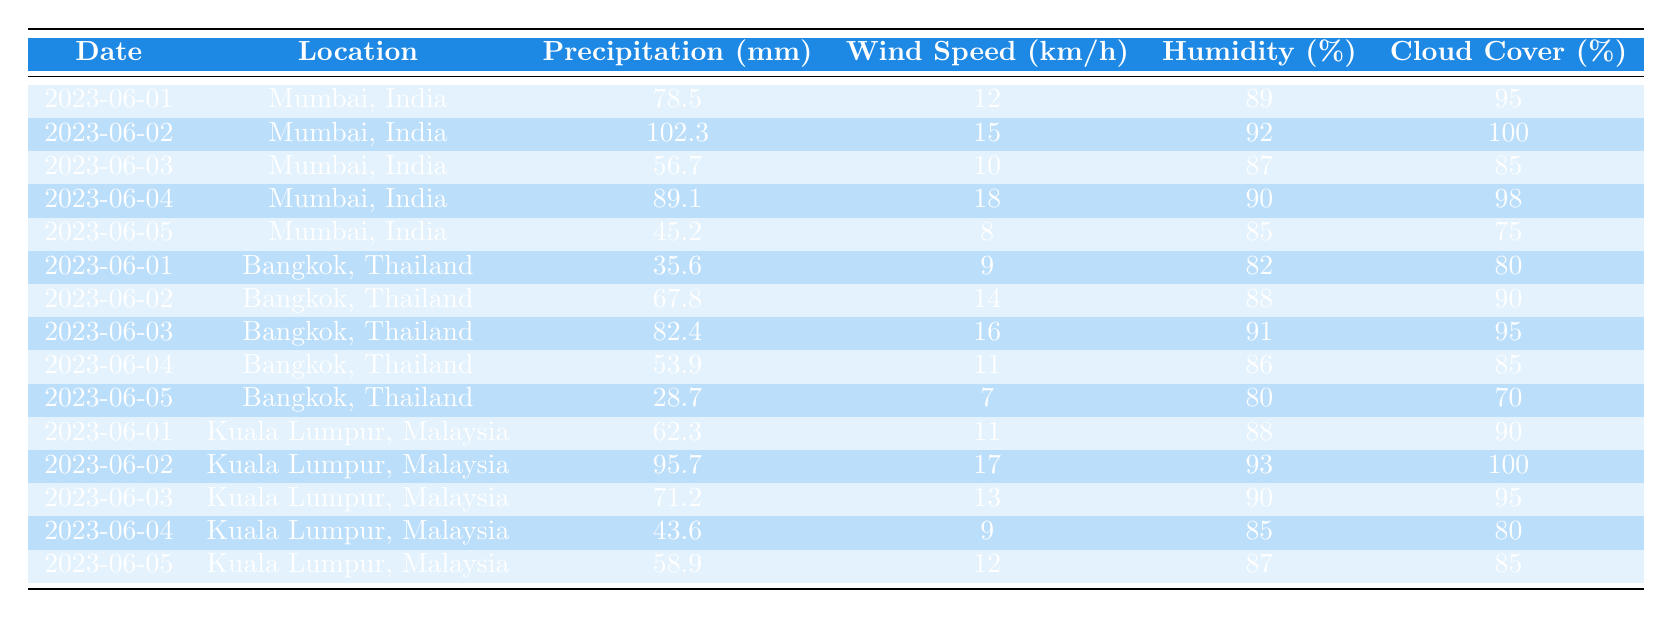What is the highest precipitation recorded in Mumbai during this period? Looking at the table, the precipitation values for Mumbai are 78.5, 102.3, 56.7, 89.1, and 45.2 mm. The highest value among them is 102.3 mm on June 2nd.
Answer: 102.3 mm What was the maximum wind speed observed in Bangkok? The wind speeds for Bangkok on the given dates are 9, 14, 16, 11, and 7 km/h. The maximum value is 16 km/h on June 3rd.
Answer: 16 km/h Calculate the average humidity in Kuala Lumpur during this period. The humidity values for Kuala Lumpur are 88, 93, 90, 85, and 87%. Adding these together gives 443%. To find the average, divide by 5: 443 / 5 = 88.6%.
Answer: 88.6% Did Mumbai experience more precipitation than Kuala Lumpur on June 05? On June 5, Mumbai had 45.2 mm of precipitation while Kuala Lumpur had 58.9 mm. Since 45.2 is less than 58.9, the answer is no, Mumbai did not experience more precipitation.
Answer: No What is the total precipitation recorded across all locations on June 02? The precipitation for June 2 is as follows: Mumbai 102.3 mm, Bangkok 67.8 mm, and Kuala Lumpur 95.7 mm. Adding these gives a total of 265.8 mm for June 2.
Answer: 265.8 mm How many days did Mumbai record precipitation over 80 mm? Upon reviewing the Mumbai data, we see that the values over 80 mm are 102.3 mm (June 2), 89.1 mm (June 4), and 78.5 mm (June 1); thus, there are 2 days (June 2 and 4) with precipitation over 80 mm.
Answer: 2 days Which location had the lowest precipitation on June 05? Looking across the table, on June 5, Mumbai had 45.2 mm, Bangkok had 28.7 mm, and Kuala Lumpur had 58.9 mm. Bangkok's 28.7 mm is the lowest among them.
Answer: Bangkok What is the total cloud cover percentage observed for all days in Mumbai? The cloud cover percentages for Mumbai are 95, 100, 85, 98, and 75%. Summing these gives 453%. The total cloud cover is 453%.
Answer: 453% For which location was the humidity the highest on June 04? On June 4, the humidity readings are: Mumbai 90%, Bangkok 86%, Kuala Lumpur 85%. Comparing these, Mumbai had the highest humidity at 90%.
Answer: Mumbai How does the average wind speed in Kuala Lumpur compare to Bangkok? The wind speeds for Kuala Lumpur are 11, 17, 13, 9, and 12 km/h, yielding an average of 12.4 km/h. For Bangkok, the wind speeds are 9, 14, 16, 11, and 7 km/h, giving an average of 11.4 km/h. Comparing these, Kuala Lumpur's average wind speed (12.4 km/h) is higher than Bangkok's (11.4 km/h).
Answer: Kuala Lumpur is higher 